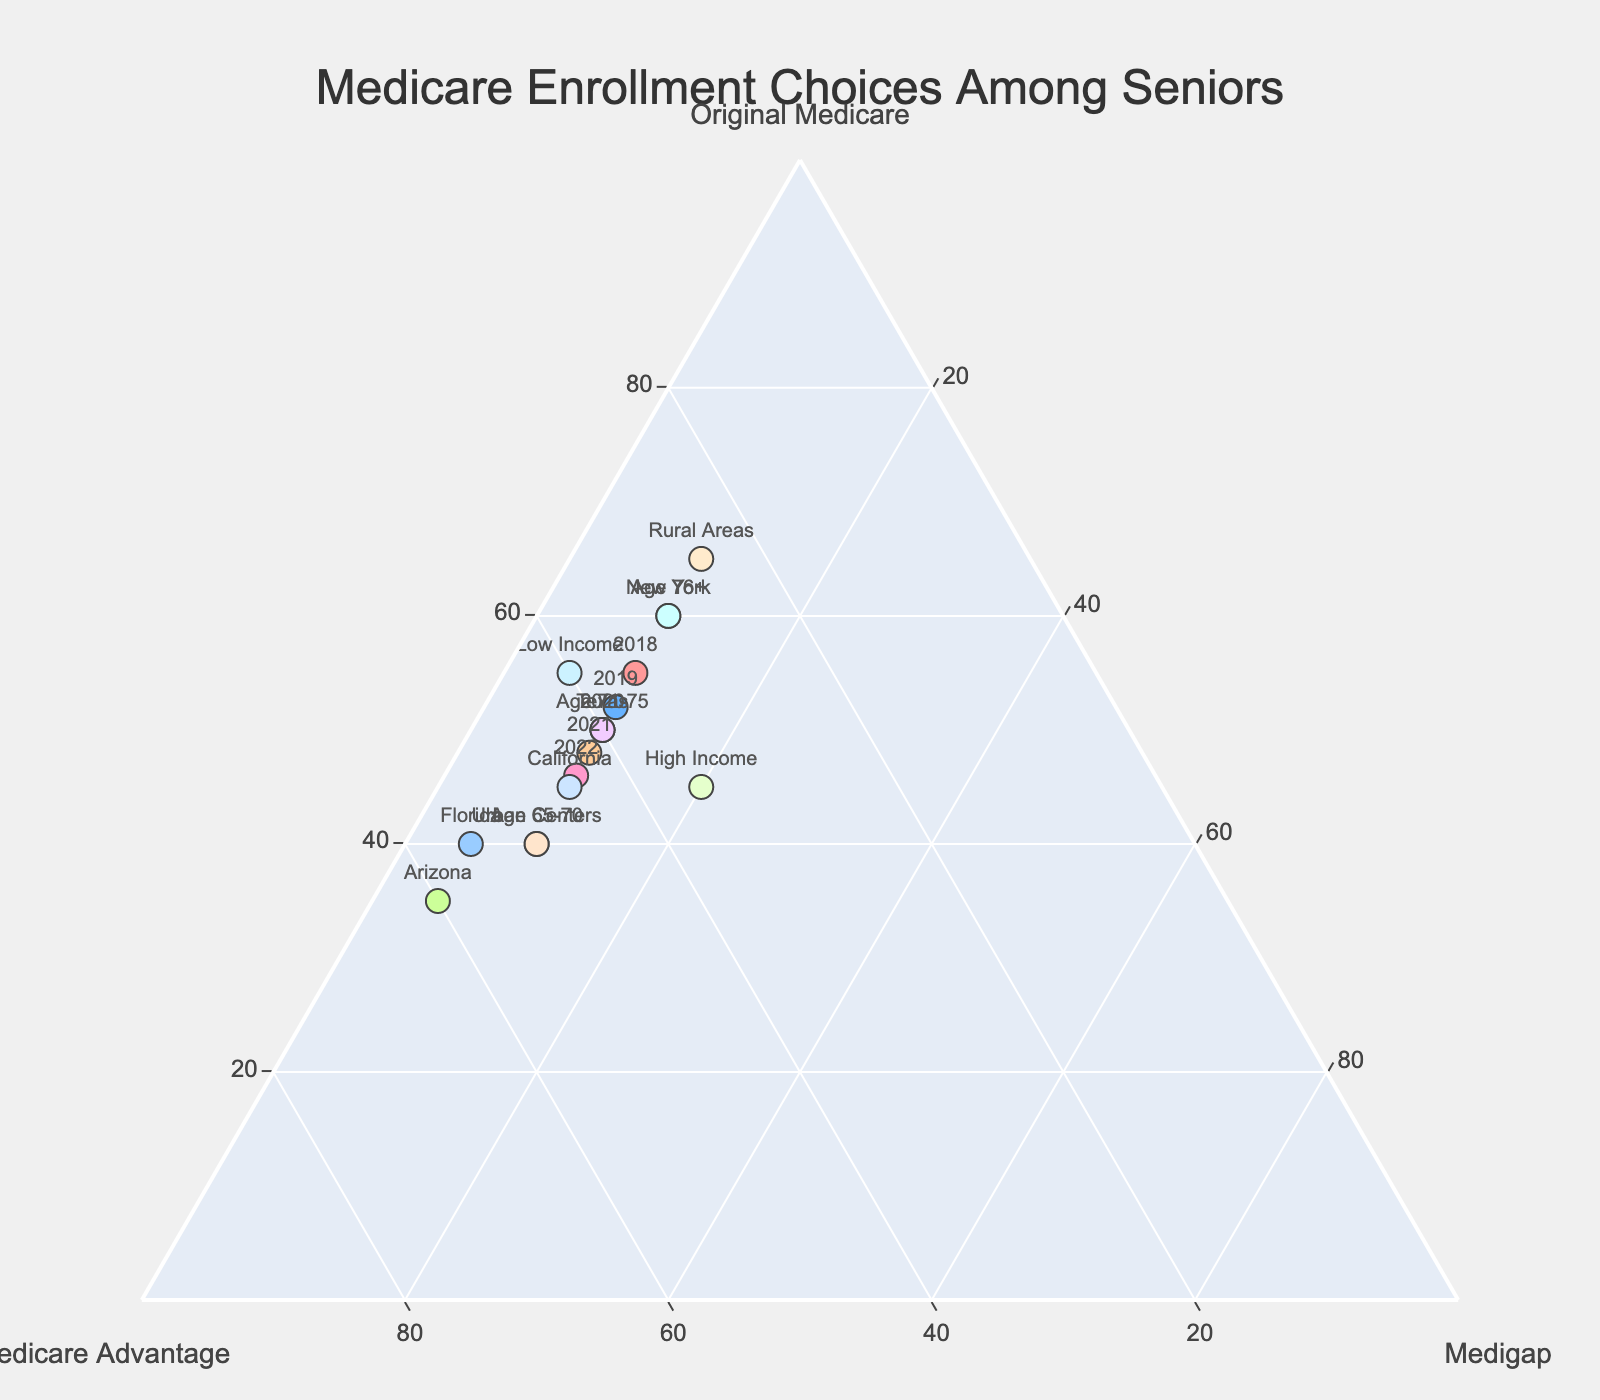How many categories are represented in the figure? The figure has three categories, as seen by the title and labels on the axes: Original Medicare, Medicare Advantage, and Medigap.
Answer: 3 What is the proportion of seniors enrolled in Original Medicare in 2020? Locate the data point labeled "2020" and read the value for Original Medicare, which is 50%.
Answer: 50% Which region shows the highest enrollment for Medicare Advantage? Find the data points representing different regions and identify the one with the highest Medicare Advantage value, which is Arizona at 60%.
Answer: Arizona How does the enrollment in Original Medicare change from 2018 to 2022? Compare the percentages of Original Medicare for each year from 2018 (55%) to 2022 (46%). The enrollment decreases.
Answer: Decreases What is the combined percentage of seniors in California enrolled in Original Medicare and Medicare Advantage? Add the given percentages for California in Original Medicare (45%) and Medicare Advantage (45%): 45% + 45% = 90%.
Answer: 90% Which income group has a higher percentage in Medigap, and what is it? Compare the Medigap values for Low Income (5%) and High Income (20%). High Income has a higher percentage.
Answer: High Income, 20% What percentage of seniors in rural areas are enrolled in Medicare Advantage? Locate the data point labeled "Rural Areas" and read the value for Medicare Advantage, which is 25%.
Answer: 25% Does urban or rural areas have higher enrollment in Original Medicare, and by how much? Compare the Original Medicare values for Urban Centers (40%) and Rural Areas (65%). Rural Areas have a higher enrollment by 65% - 40% = 25%.
Answer: Rural, 25% How does Medicare Advantage enrollment differ between the age groups 65-70 and 76+? Locate the data points for each age group and compare the Medicare Advantage values: 65-70 has 50% and 76+ has 30%. The difference is 50% - 30% = 20%.
Answer: 20% What is the most common Medicare plan choice for seniors in Florida? Find the data point labeled "Florida" and determine which category has the highest percentage. Medicare Advantage has the highest at 55%.
Answer: Medicare Advantage 